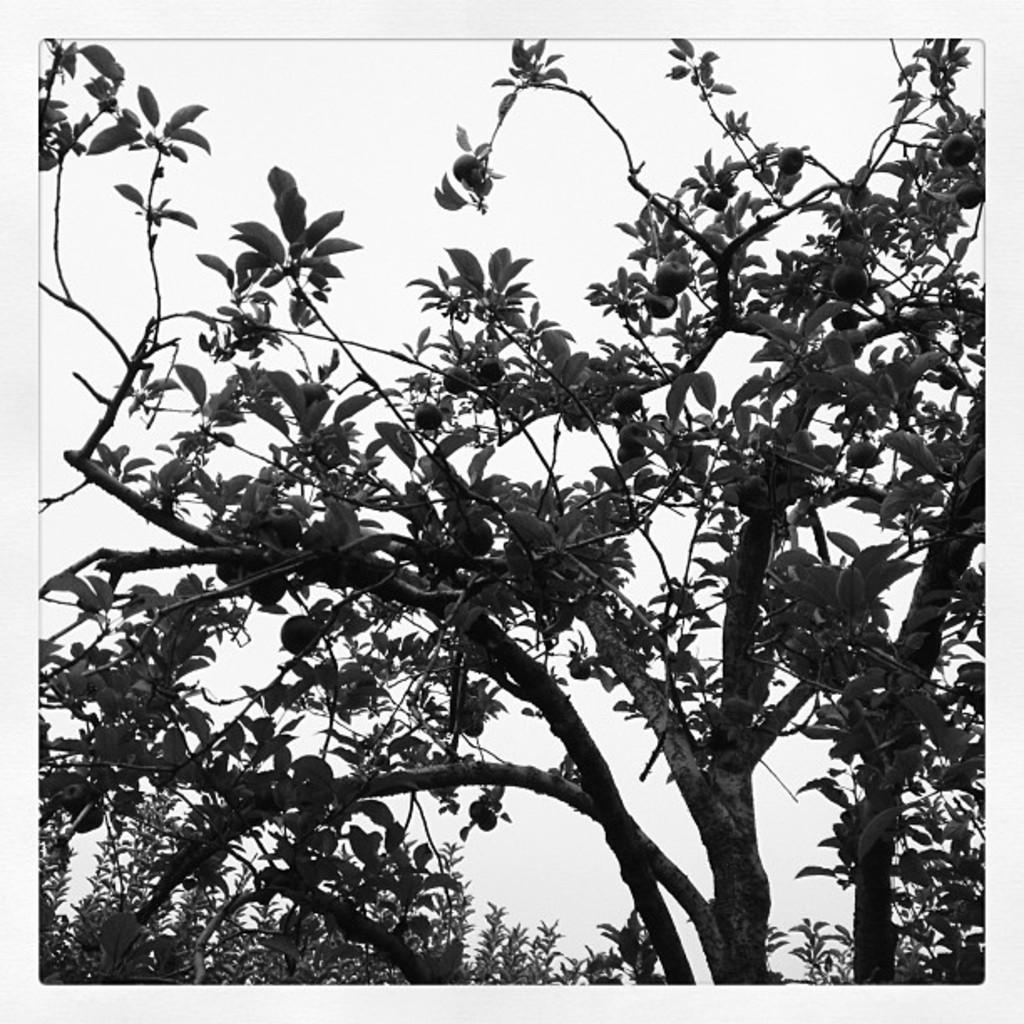What is the color scheme of the image? The image is black and white. What type of vegetation can be seen in the image? There are trees in the image. Are there any fruits visible in the image? Yes, there are fruits on the tree in the center of the image. What is the border of the image like? The image has a white border. Can you see any signs of a rainstorm in the image? There is no indication of a rainstorm in the image; it is a black and white image of trees with fruits. Is there a trail visible in the image? There is no trail visible in the image; it only shows trees and fruits. 